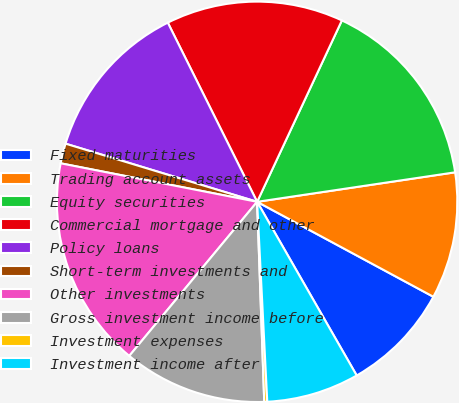<chart> <loc_0><loc_0><loc_500><loc_500><pie_chart><fcel>Fixed maturities<fcel>Trading account assets<fcel>Equity securities<fcel>Commercial mortgage and other<fcel>Policy loans<fcel>Short-term investments and<fcel>Other investments<fcel>Gross investment income before<fcel>Investment expenses<fcel>Investment income after<nl><fcel>8.85%<fcel>10.22%<fcel>15.69%<fcel>14.32%<fcel>12.95%<fcel>1.61%<fcel>17.06%<fcel>11.59%<fcel>0.24%<fcel>7.48%<nl></chart> 